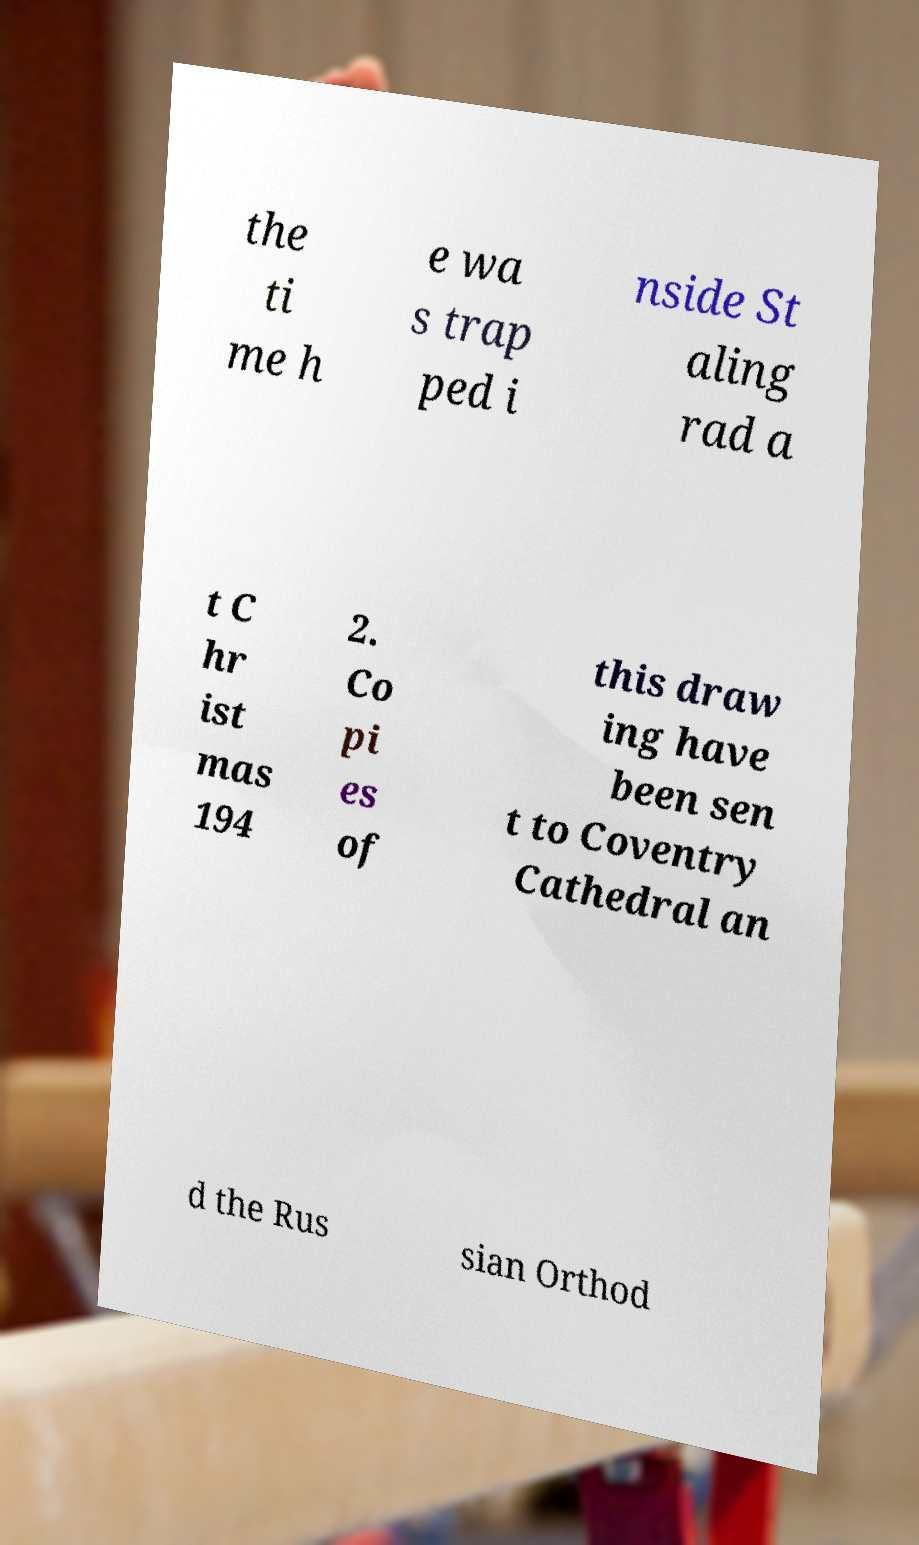Can you accurately transcribe the text from the provided image for me? the ti me h e wa s trap ped i nside St aling rad a t C hr ist mas 194 2. Co pi es of this draw ing have been sen t to Coventry Cathedral an d the Rus sian Orthod 